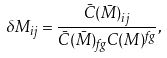Convert formula to latex. <formula><loc_0><loc_0><loc_500><loc_500>\delta M _ { i j } = \frac { \bar { C } ( \bar { M } ) _ { i j } } { \bar { C } ( \bar { M } ) _ { f g } C ( M ) ^ { f g } } ,</formula> 